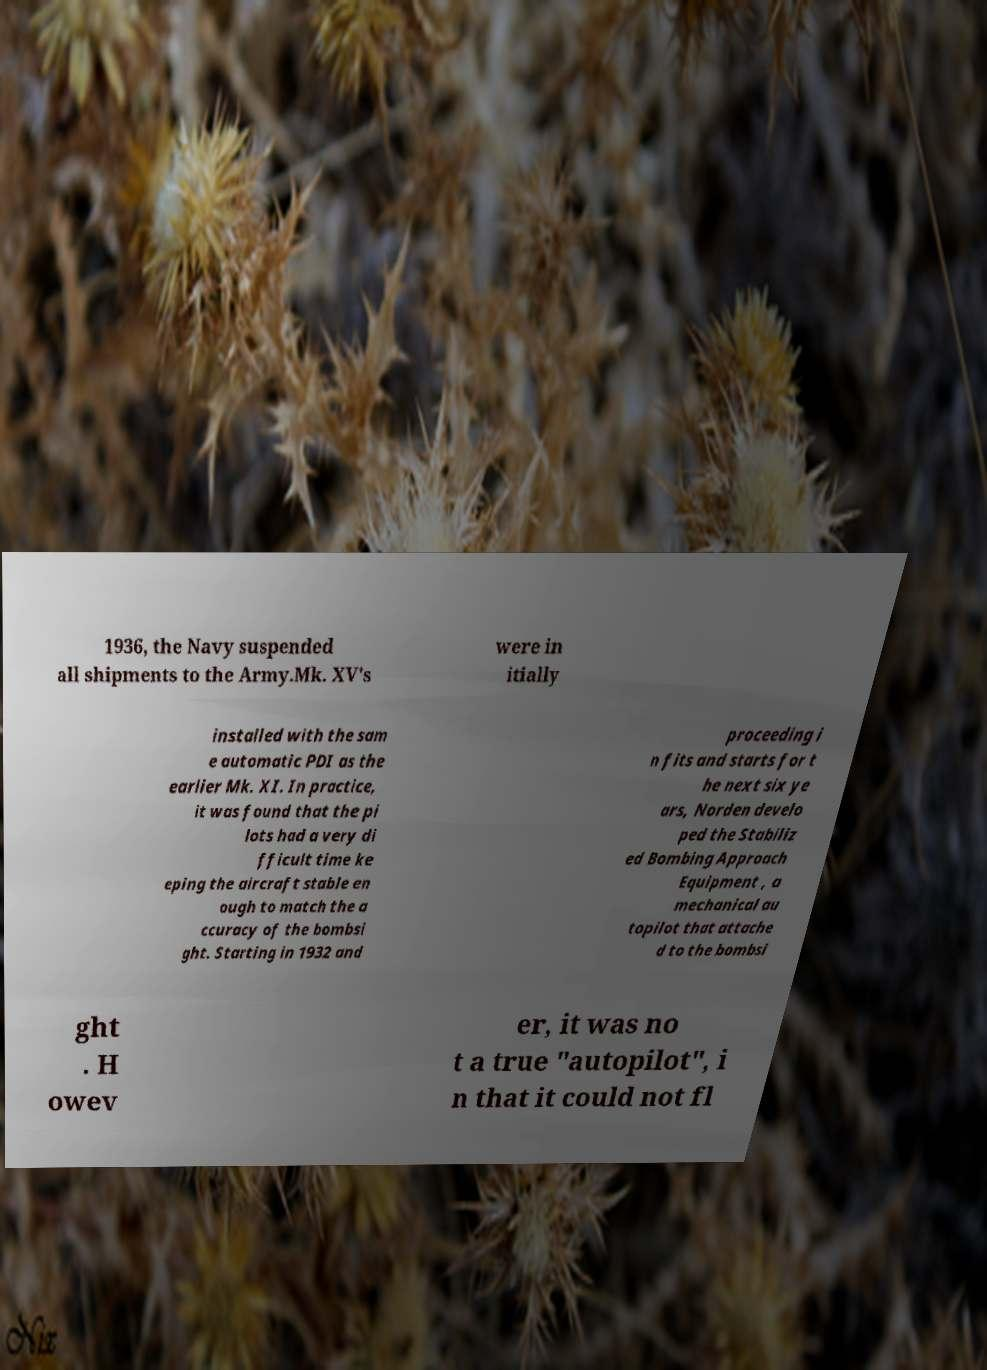There's text embedded in this image that I need extracted. Can you transcribe it verbatim? 1936, the Navy suspended all shipments to the Army.Mk. XV's were in itially installed with the sam e automatic PDI as the earlier Mk. XI. In practice, it was found that the pi lots had a very di fficult time ke eping the aircraft stable en ough to match the a ccuracy of the bombsi ght. Starting in 1932 and proceeding i n fits and starts for t he next six ye ars, Norden develo ped the Stabiliz ed Bombing Approach Equipment , a mechanical au topilot that attache d to the bombsi ght . H owev er, it was no t a true "autopilot", i n that it could not fl 